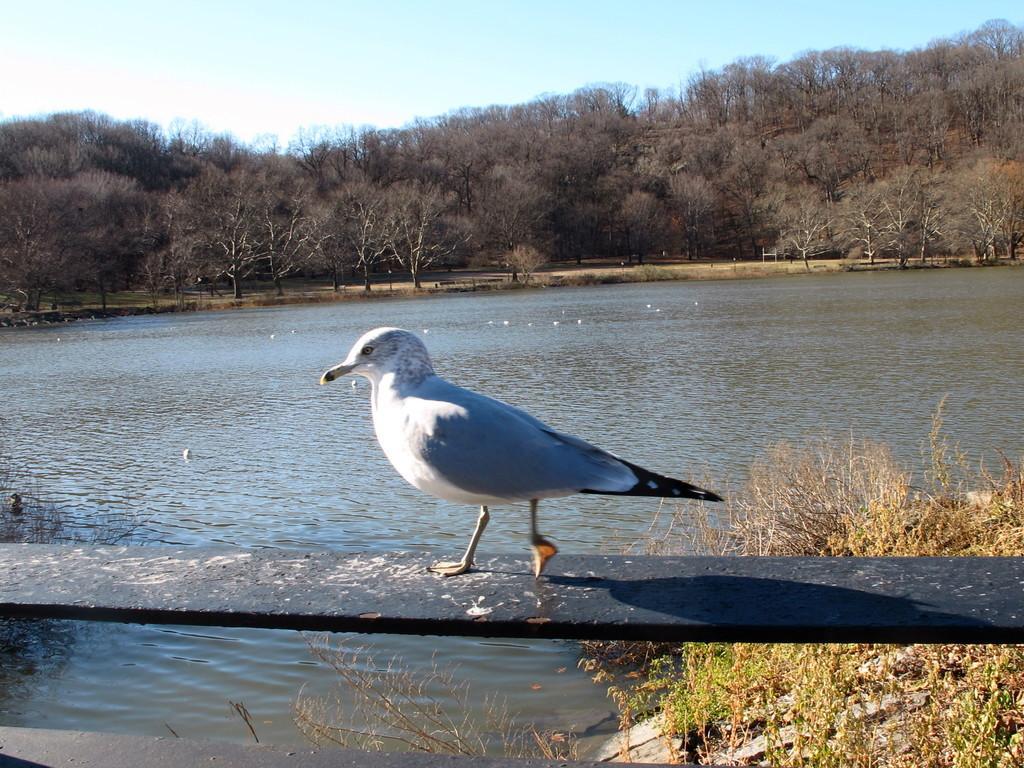Can you describe this image briefly? In the foreground of this image, there is a bird on a wooden plank like an object. Under it, there is water and few plants. In the background, there is water, trees and the sky. 